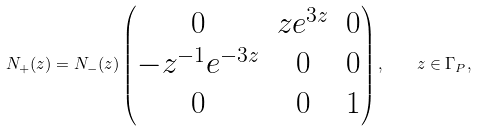<formula> <loc_0><loc_0><loc_500><loc_500>N _ { + } ( z ) = N _ { - } ( z ) \begin{pmatrix} 0 & z e ^ { 3 z } & 0 \\ - z ^ { - 1 } e ^ { - 3 z } & 0 & 0 \\ 0 & 0 & 1 \end{pmatrix} , \quad z \in \Gamma _ { P } ,</formula> 